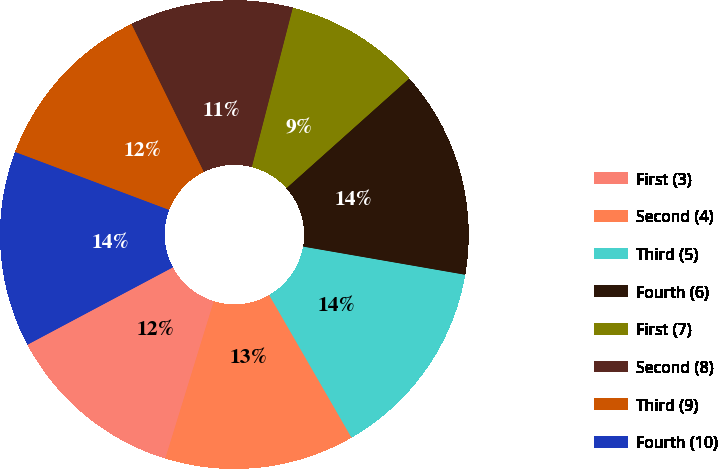Convert chart to OTSL. <chart><loc_0><loc_0><loc_500><loc_500><pie_chart><fcel>First (3)<fcel>Second (4)<fcel>Third (5)<fcel>Fourth (6)<fcel>First (7)<fcel>Second (8)<fcel>Third (9)<fcel>Fourth (10)<nl><fcel>12.46%<fcel>13.09%<fcel>13.93%<fcel>14.35%<fcel>9.38%<fcel>11.25%<fcel>12.03%<fcel>13.51%<nl></chart> 